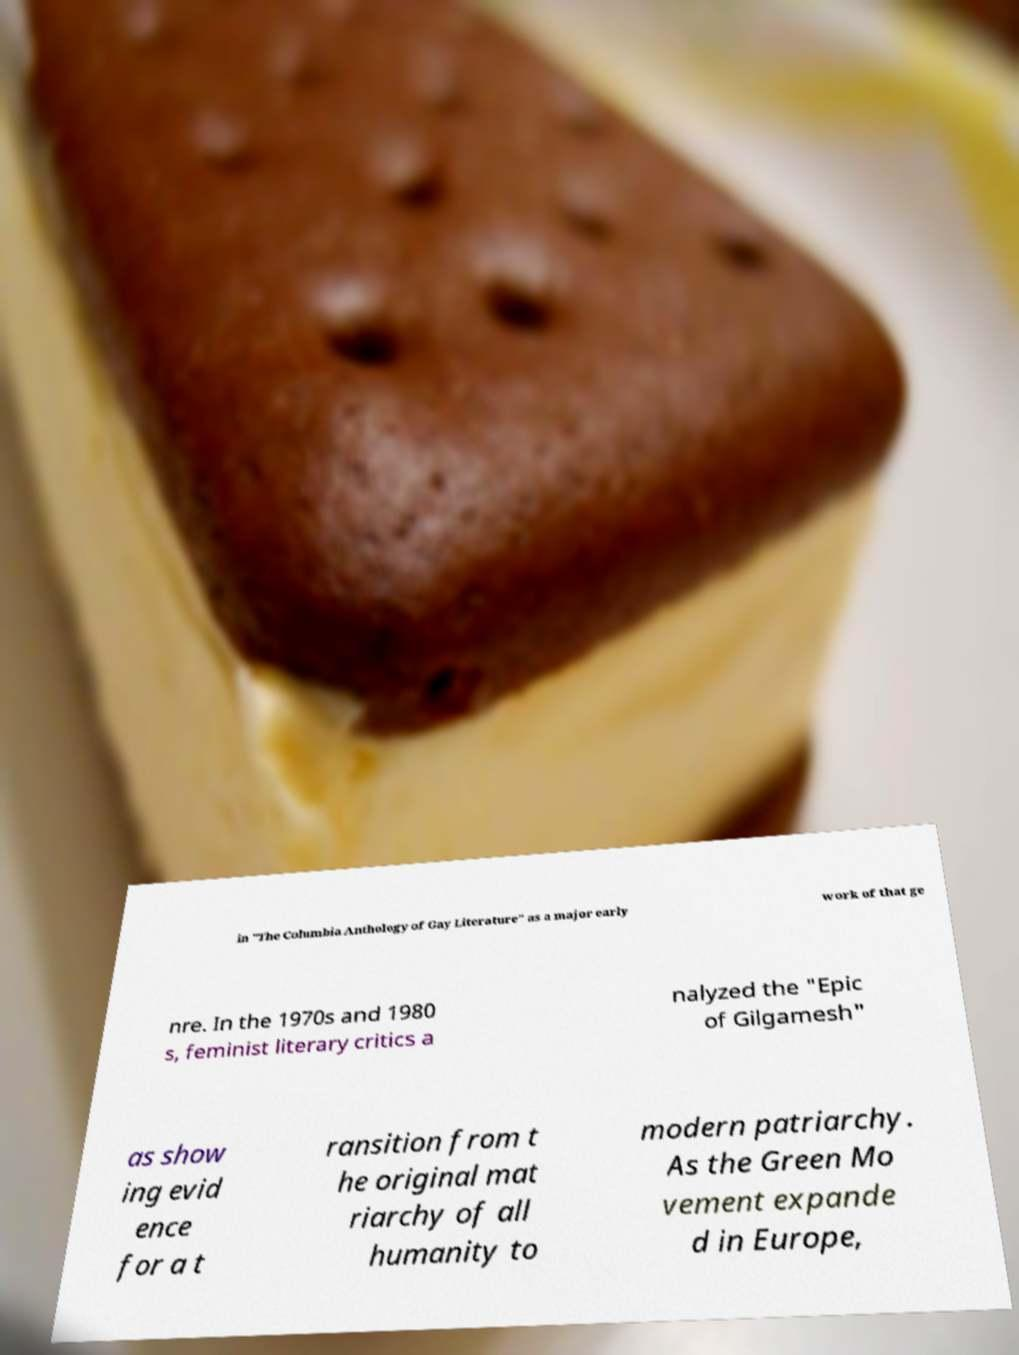I need the written content from this picture converted into text. Can you do that? in "The Columbia Anthology of Gay Literature" as a major early work of that ge nre. In the 1970s and 1980 s, feminist literary critics a nalyzed the "Epic of Gilgamesh" as show ing evid ence for a t ransition from t he original mat riarchy of all humanity to modern patriarchy. As the Green Mo vement expande d in Europe, 